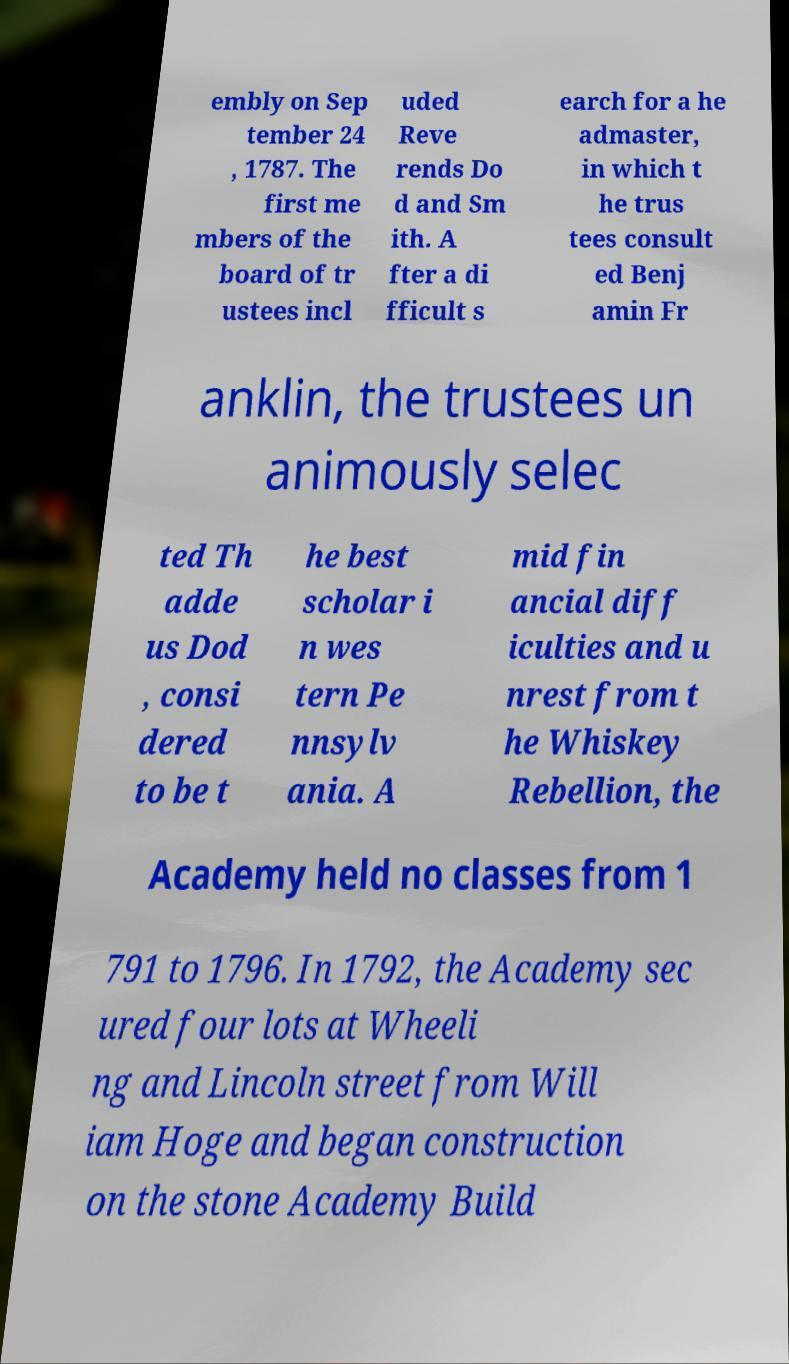Could you extract and type out the text from this image? embly on Sep tember 24 , 1787. The first me mbers of the board of tr ustees incl uded Reve rends Do d and Sm ith. A fter a di fficult s earch for a he admaster, in which t he trus tees consult ed Benj amin Fr anklin, the trustees un animously selec ted Th adde us Dod , consi dered to be t he best scholar i n wes tern Pe nnsylv ania. A mid fin ancial diff iculties and u nrest from t he Whiskey Rebellion, the Academy held no classes from 1 791 to 1796. In 1792, the Academy sec ured four lots at Wheeli ng and Lincoln street from Will iam Hoge and began construction on the stone Academy Build 